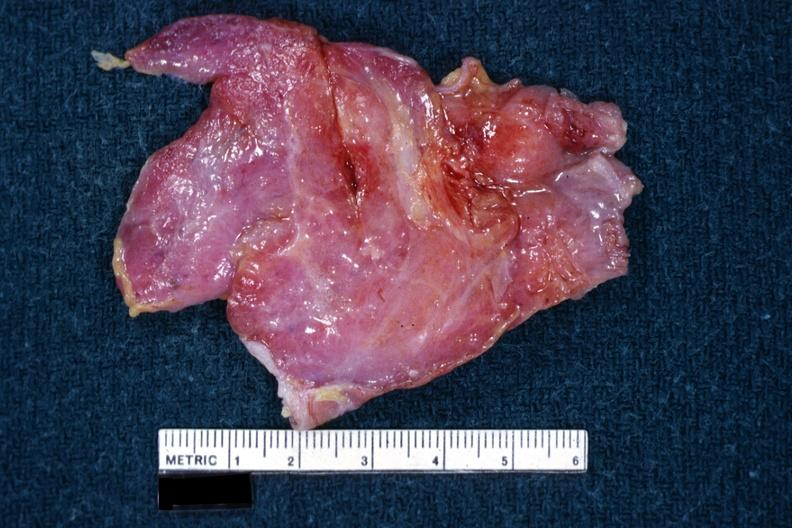s vasculature present?
Answer the question using a single word or phrase. No 